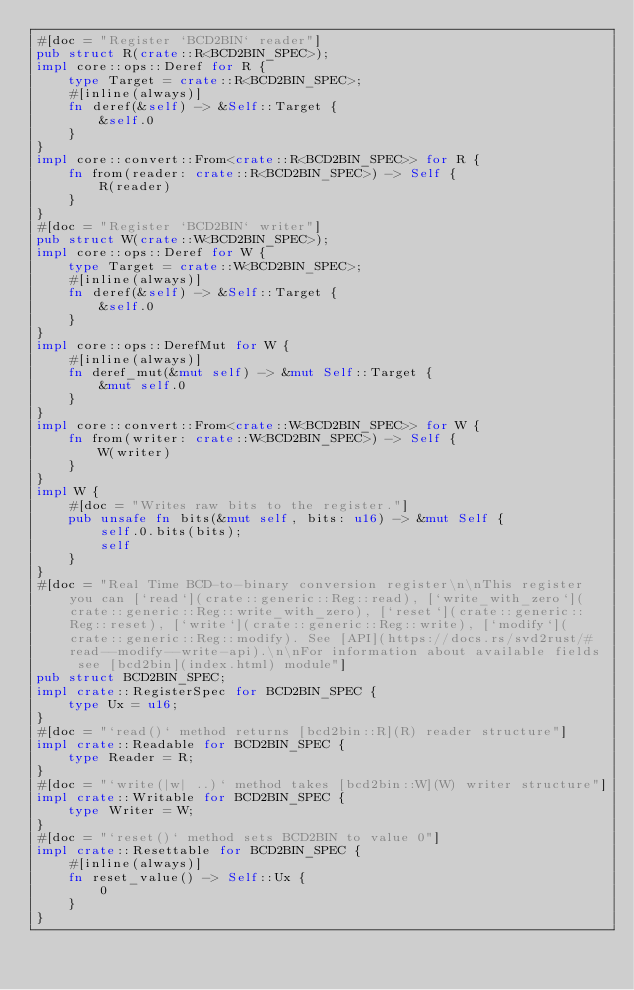<code> <loc_0><loc_0><loc_500><loc_500><_Rust_>#[doc = "Register `BCD2BIN` reader"]
pub struct R(crate::R<BCD2BIN_SPEC>);
impl core::ops::Deref for R {
    type Target = crate::R<BCD2BIN_SPEC>;
    #[inline(always)]
    fn deref(&self) -> &Self::Target {
        &self.0
    }
}
impl core::convert::From<crate::R<BCD2BIN_SPEC>> for R {
    fn from(reader: crate::R<BCD2BIN_SPEC>) -> Self {
        R(reader)
    }
}
#[doc = "Register `BCD2BIN` writer"]
pub struct W(crate::W<BCD2BIN_SPEC>);
impl core::ops::Deref for W {
    type Target = crate::W<BCD2BIN_SPEC>;
    #[inline(always)]
    fn deref(&self) -> &Self::Target {
        &self.0
    }
}
impl core::ops::DerefMut for W {
    #[inline(always)]
    fn deref_mut(&mut self) -> &mut Self::Target {
        &mut self.0
    }
}
impl core::convert::From<crate::W<BCD2BIN_SPEC>> for W {
    fn from(writer: crate::W<BCD2BIN_SPEC>) -> Self {
        W(writer)
    }
}
impl W {
    #[doc = "Writes raw bits to the register."]
    pub unsafe fn bits(&mut self, bits: u16) -> &mut Self {
        self.0.bits(bits);
        self
    }
}
#[doc = "Real Time BCD-to-binary conversion register\n\nThis register you can [`read`](crate::generic::Reg::read), [`write_with_zero`](crate::generic::Reg::write_with_zero), [`reset`](crate::generic::Reg::reset), [`write`](crate::generic::Reg::write), [`modify`](crate::generic::Reg::modify). See [API](https://docs.rs/svd2rust/#read--modify--write-api).\n\nFor information about available fields see [bcd2bin](index.html) module"]
pub struct BCD2BIN_SPEC;
impl crate::RegisterSpec for BCD2BIN_SPEC {
    type Ux = u16;
}
#[doc = "`read()` method returns [bcd2bin::R](R) reader structure"]
impl crate::Readable for BCD2BIN_SPEC {
    type Reader = R;
}
#[doc = "`write(|w| ..)` method takes [bcd2bin::W](W) writer structure"]
impl crate::Writable for BCD2BIN_SPEC {
    type Writer = W;
}
#[doc = "`reset()` method sets BCD2BIN to value 0"]
impl crate::Resettable for BCD2BIN_SPEC {
    #[inline(always)]
    fn reset_value() -> Self::Ux {
        0
    }
}
</code> 